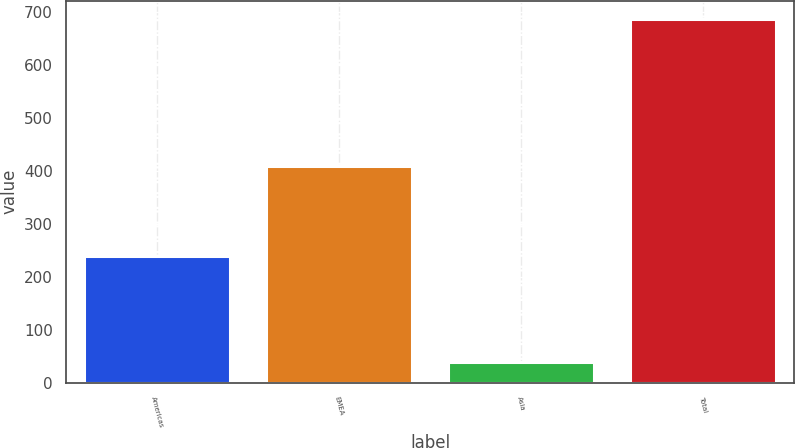<chart> <loc_0><loc_0><loc_500><loc_500><bar_chart><fcel>Americas<fcel>EMEA<fcel>Asia<fcel>Total<nl><fcel>239<fcel>409<fcel>39<fcel>687<nl></chart> 